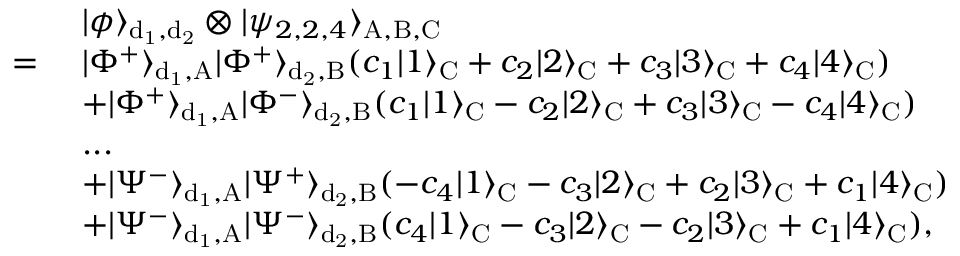Convert formula to latex. <formula><loc_0><loc_0><loc_500><loc_500>\begin{array} { r l } & { | \phi \rangle _ { d _ { 1 } , d _ { 2 } } \otimes | \psi _ { 2 , 2 , 4 } \rangle _ { A , B , C } } \\ { = } & { | \Phi ^ { + } \rangle _ { d _ { 1 } , A } | \Phi ^ { + } \rangle _ { d _ { 2 } , B } ( c _ { 1 } | 1 \rangle _ { C } + c _ { 2 } | 2 \rangle _ { C } + c _ { 3 } | 3 \rangle _ { C } + c _ { 4 } | 4 \rangle _ { C } ) } \\ & { + | \Phi ^ { + } \rangle _ { d _ { 1 } , A } | \Phi ^ { - } \rangle _ { d _ { 2 } , B } ( c _ { 1 } | 1 \rangle _ { C } - c _ { 2 } | 2 \rangle _ { C } + c _ { 3 } | 3 \rangle _ { C } - c _ { 4 } | 4 \rangle _ { C } ) } \\ & { \dots } \\ & { + | \Psi ^ { - } \rangle _ { d _ { 1 } , A } | \Psi ^ { + } \rangle _ { d _ { 2 } , B } ( - c _ { 4 } | 1 \rangle _ { C } - c _ { 3 } | 2 \rangle _ { C } + c _ { 2 } | 3 \rangle _ { C } + c _ { 1 } | 4 \rangle _ { C } ) } \\ & { + | \Psi ^ { - } \rangle _ { d _ { 1 } , A } | \Psi ^ { - } \rangle _ { d _ { 2 } , B } ( c _ { 4 } | 1 \rangle _ { C } - c _ { 3 } | 2 \rangle _ { C } - c _ { 2 } | 3 \rangle _ { C } + c _ { 1 } | 4 \rangle _ { C } ) , } \end{array}</formula> 